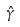<formula> <loc_0><loc_0><loc_500><loc_500>\hat { \gamma }</formula> 